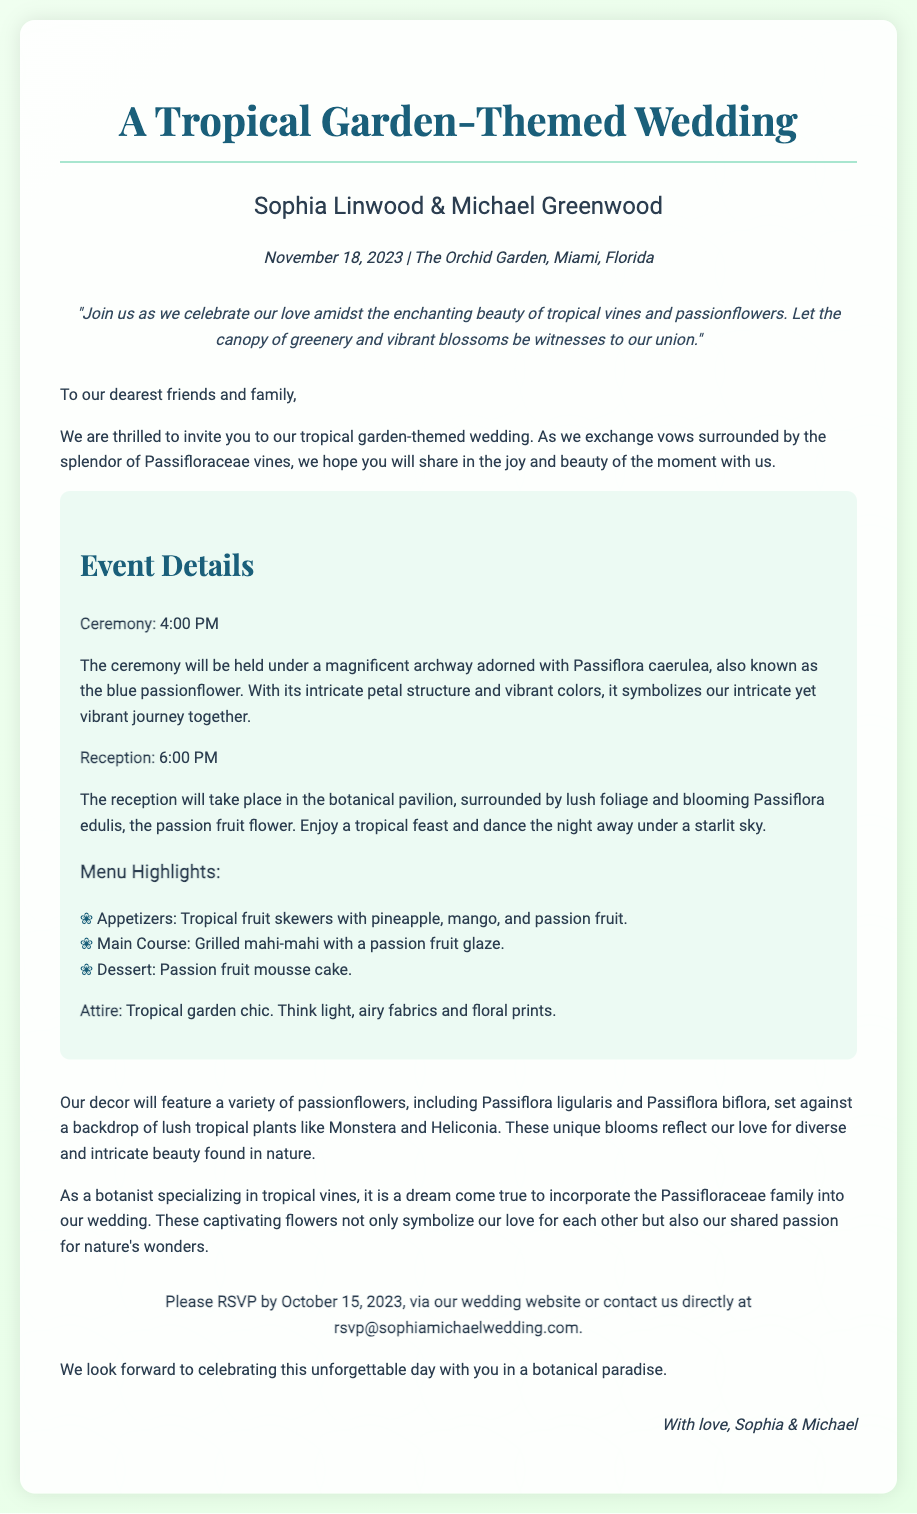what date is the wedding? The wedding is on November 18, 2023, as stated in the document.
Answer: November 18, 2023 who are the couple getting married? The couple mentioned in the invitation are Sophia Linwood and Michael Greenwood.
Answer: Sophia Linwood & Michael Greenwood what is the location of the ceremony? The ceremony will take place at The Orchid Garden in Miami, Florida, according to the invitation details.
Answer: The Orchid Garden, Miami, Florida what is the time for the reception? The reception is set to take place at 6:00 PM, as provided in the event details.
Answer: 6:00 PM what type of flowers will decorate the ceremony? The document specifies that the ceremony will be adorned with Passiflora caerulea, also known as the blue passionflower.
Answer: Passiflora caerulea how should guests dress for the wedding? The attire requested is described as tropical garden chic with light fabrics and floral prints.
Answer: Tropical garden chic why are passionflowers significant to the couple? The couple expresses that the passionflowers symbolize their love and shared passion for nature's wonders.
Answer: Symbolize their love and shared passion for nature's wonders when is the RSVP deadline? The RSVP deadline is mentioned to be October 15, 2023, in the invitation.
Answer: October 15, 2023 